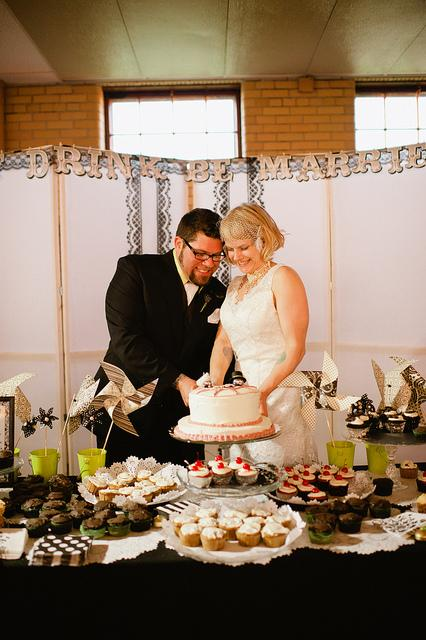What are the two touching?

Choices:
A) brownies
B) cake
C) pie
D) muffins cake 